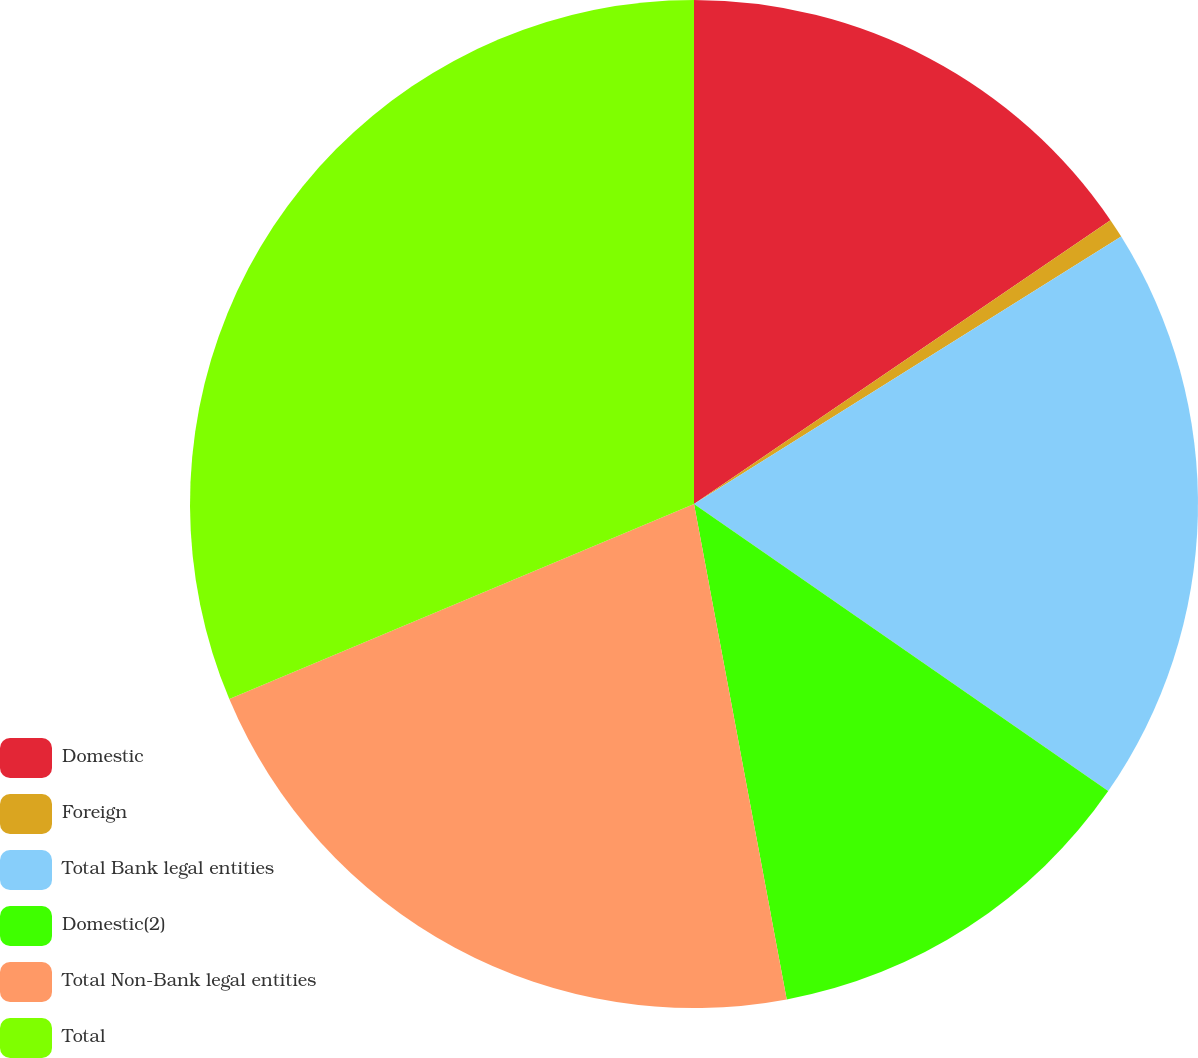<chart> <loc_0><loc_0><loc_500><loc_500><pie_chart><fcel>Domestic<fcel>Foreign<fcel>Total Bank legal entities<fcel>Domestic(2)<fcel>Total Non-Bank legal entities<fcel>Total<nl><fcel>15.48%<fcel>0.62%<fcel>18.55%<fcel>12.41%<fcel>21.62%<fcel>31.33%<nl></chart> 